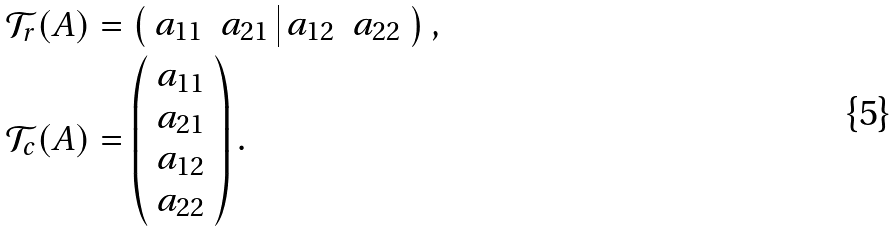<formula> <loc_0><loc_0><loc_500><loc_500>\mathcal { T } _ { r } ( A ) & = \left ( \begin{array} { c c | c c } a _ { 1 1 } & a _ { 2 1 } & a _ { 1 2 } & a _ { 2 2 } \end{array} \right ) , \\ \mathcal { T } _ { c } ( A ) & = \left ( \begin{array} { c } a _ { 1 1 } \\ a _ { 2 1 } \\ a _ { 1 2 } \\ a _ { 2 2 } \end{array} \right ) .</formula> 